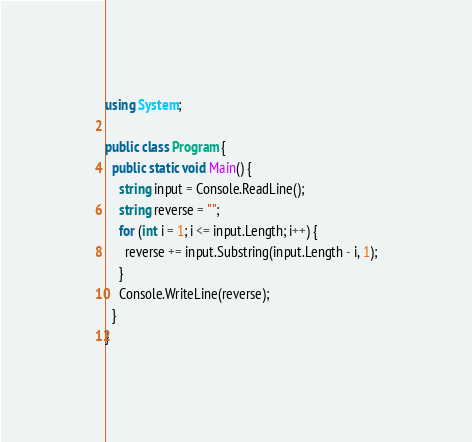Convert code to text. <code><loc_0><loc_0><loc_500><loc_500><_C#_>using System;

public class Program {
  public static void Main() {
    string input = Console.ReadLine();
    string reverse = "";
    for (int i = 1; i <= input.Length; i++) {
      reverse += input.Substring(input.Length - i, 1);
    }
    Console.WriteLine(reverse);
  }
}</code> 